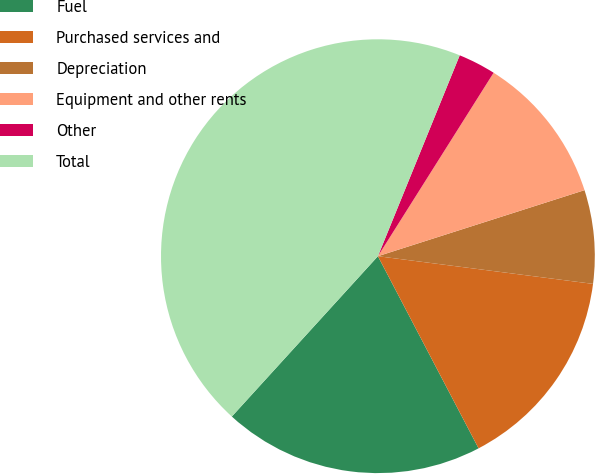Convert chart. <chart><loc_0><loc_0><loc_500><loc_500><pie_chart><fcel>Fuel<fcel>Purchased services and<fcel>Depreciation<fcel>Equipment and other rents<fcel>Other<fcel>Total<nl><fcel>19.44%<fcel>15.28%<fcel>6.96%<fcel>11.12%<fcel>2.8%<fcel>44.39%<nl></chart> 